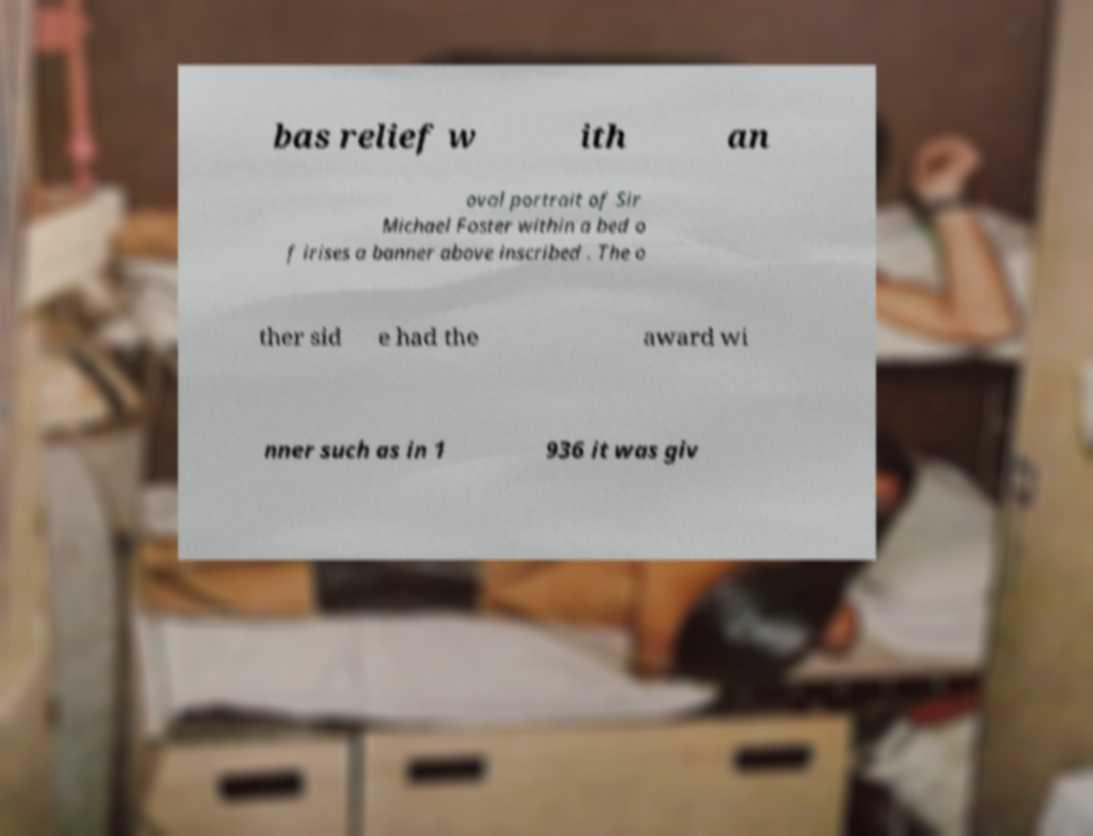Could you extract and type out the text from this image? bas relief w ith an oval portrait of Sir Michael Foster within a bed o f irises a banner above inscribed . The o ther sid e had the award wi nner such as in 1 936 it was giv 